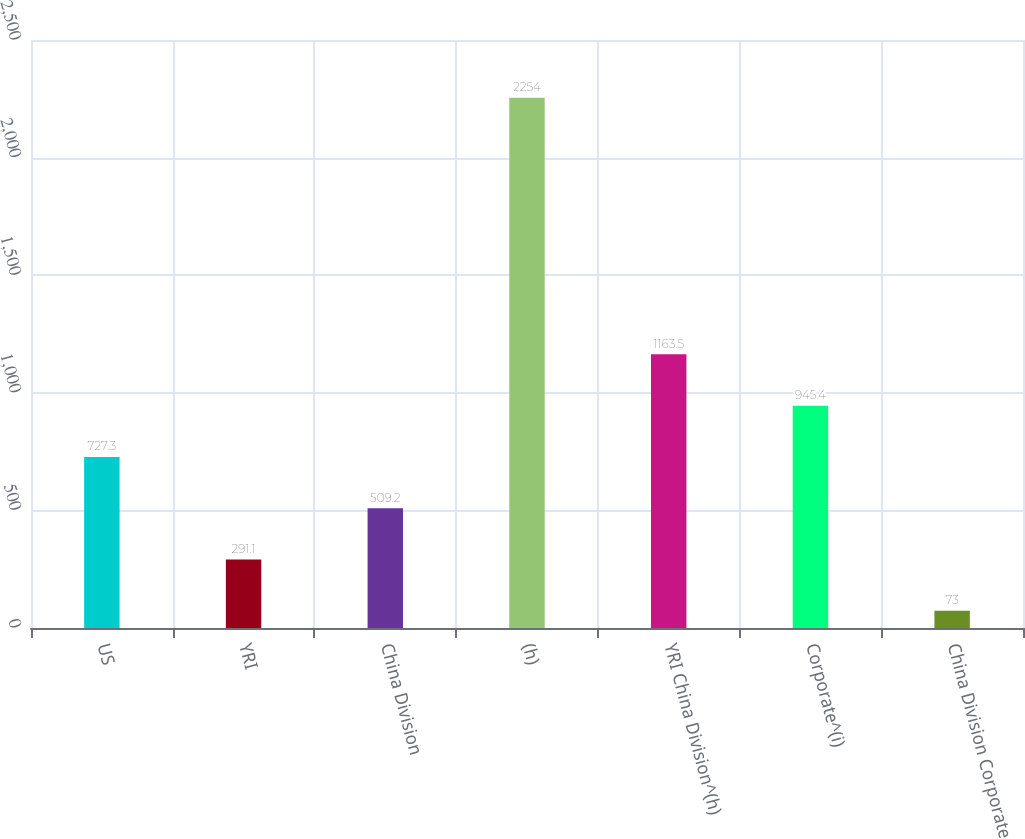<chart> <loc_0><loc_0><loc_500><loc_500><bar_chart><fcel>US<fcel>YRI<fcel>China Division<fcel>(h)<fcel>YRI China Division^(h)<fcel>Corporate^(i)<fcel>China Division Corporate<nl><fcel>727.3<fcel>291.1<fcel>509.2<fcel>2254<fcel>1163.5<fcel>945.4<fcel>73<nl></chart> 